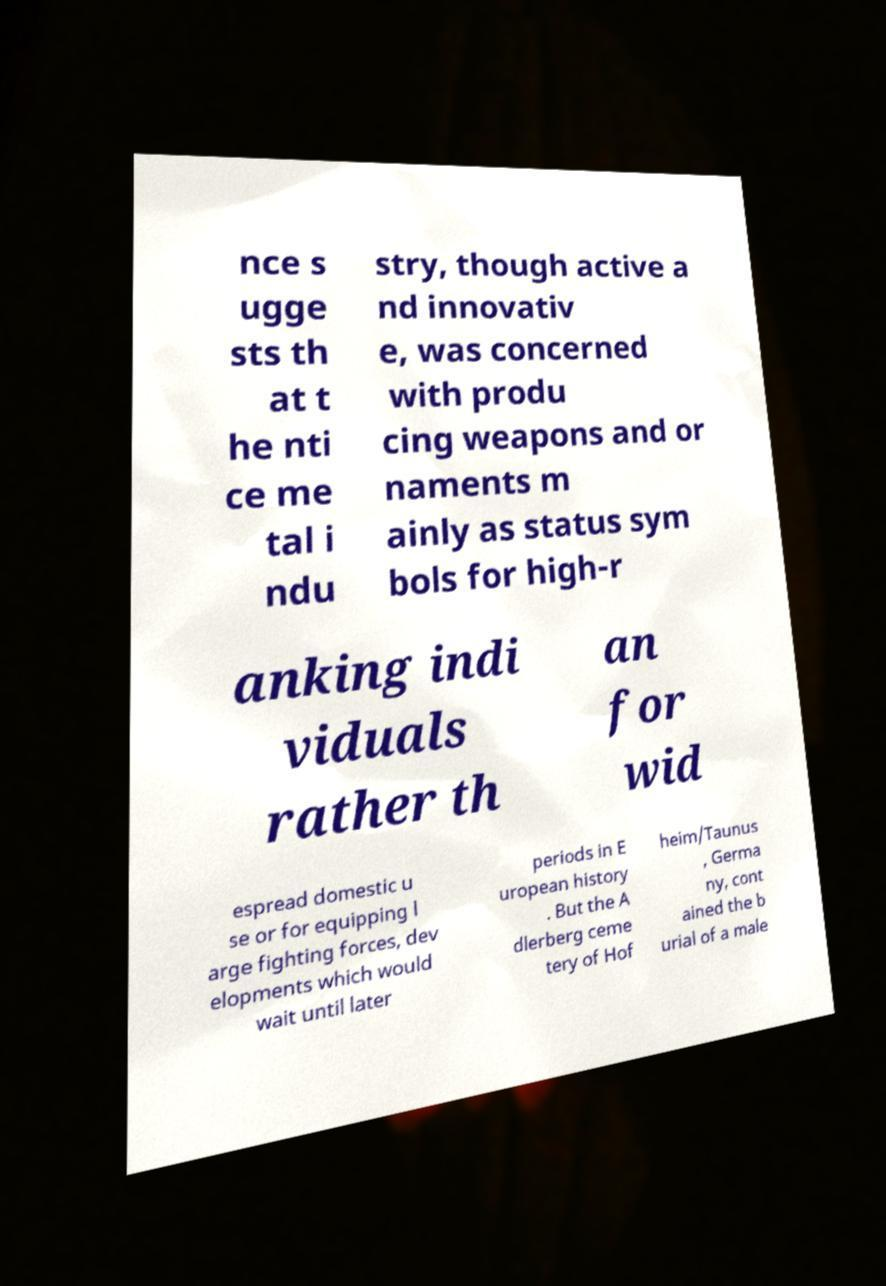I need the written content from this picture converted into text. Can you do that? nce s ugge sts th at t he nti ce me tal i ndu stry, though active a nd innovativ e, was concerned with produ cing weapons and or naments m ainly as status sym bols for high-r anking indi viduals rather th an for wid espread domestic u se or for equipping l arge fighting forces, dev elopments which would wait until later periods in E uropean history . But the A dlerberg ceme tery of Hof heim/Taunus , Germa ny, cont ained the b urial of a male 